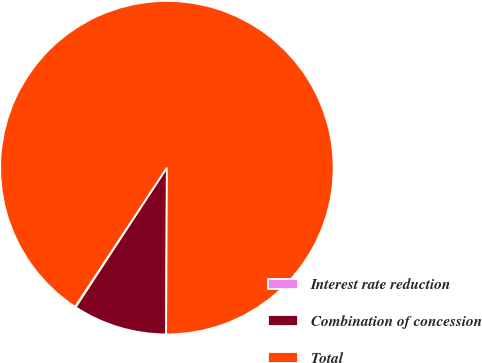Convert chart. <chart><loc_0><loc_0><loc_500><loc_500><pie_chart><fcel>Interest rate reduction<fcel>Combination of concession<fcel>Total<nl><fcel>0.07%<fcel>9.14%<fcel>90.78%<nl></chart> 